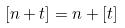<formula> <loc_0><loc_0><loc_500><loc_500>[ n + t ] = n + [ t ]</formula> 